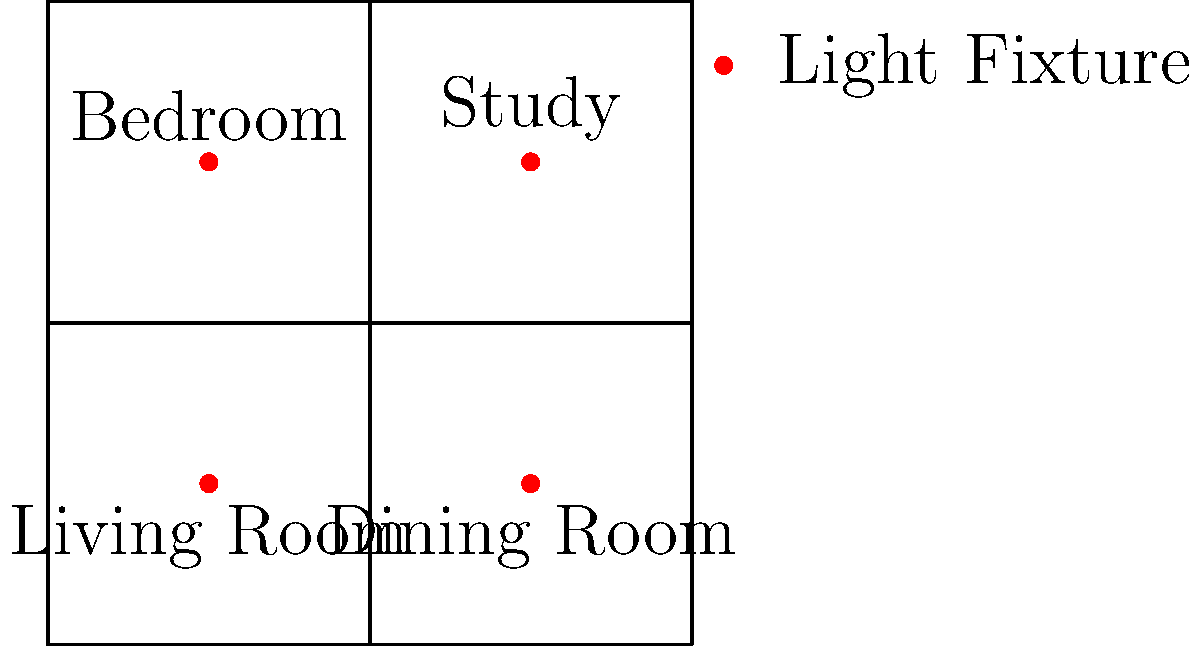Given the floor plan of a large estate with four main rooms and the placement of energy-efficient light fixtures, calculate the total lumens required to adequately illuminate the entire space if each room needs 20 lumens per square foot and the estate measures 100 feet by 100 feet. How many 1000-lumen LED bulbs would be needed to meet this requirement? To solve this problem, we'll follow these steps:

1. Calculate the total area of the estate:
   Area = length × width
   Area = 100 ft × 100 ft = 10,000 sq ft

2. Calculate the total lumens required:
   Lumens required = Area × Lumens per square foot
   Lumens required = 10,000 sq ft × 20 lumens/sq ft = 200,000 lumens

3. Calculate the number of 1000-lumen LED bulbs needed:
   Number of bulbs = Total lumens required ÷ Lumens per bulb
   Number of bulbs = 200,000 lumens ÷ 1000 lumens/bulb = 200 bulbs

Therefore, 200 LED bulbs with 1000 lumens each would be needed to adequately illuminate the entire estate according to the given requirements.
Answer: 200 LED bulbs 